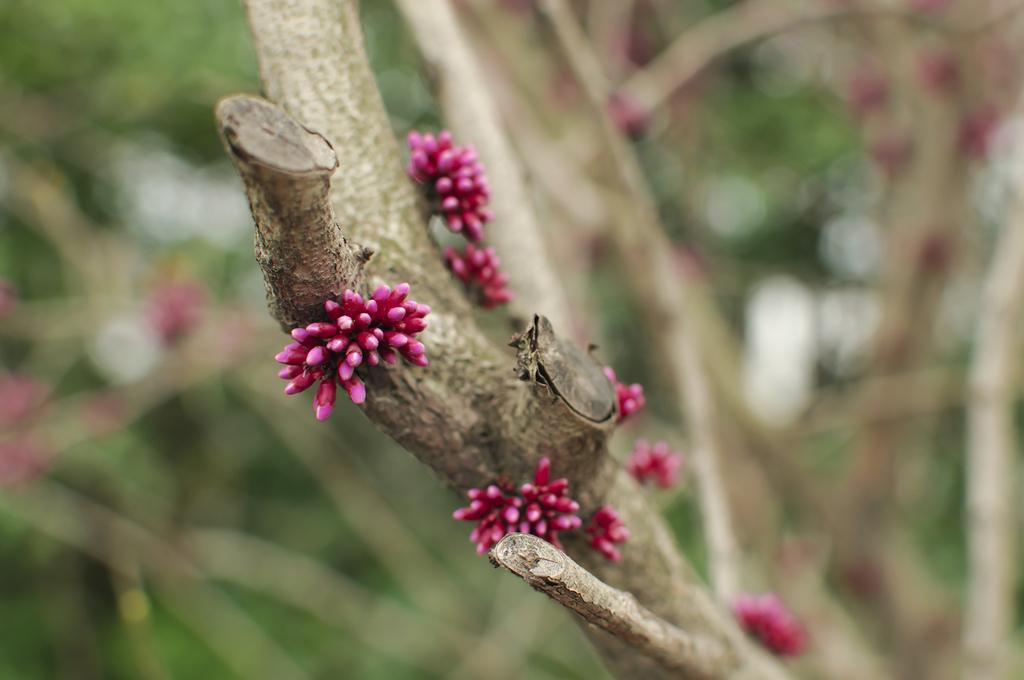What is the main subject of the image? The main subject of the image is a branch of a tree. What can be observed on the branch? The branch has pink color flowers. How would you describe the background of the image? The background of the image is blurred. Is there any bread visible in the image? No, there is no bread present in the image. Can you see any steam coming from the flowers on the branch? No, there is no steam visible in the image. 